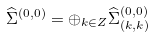<formula> <loc_0><loc_0><loc_500><loc_500>\widehat { \Sigma } ^ { ( 0 , 0 ) } = \oplus _ { k \in Z } \widehat { \Sigma } _ { ( k , k ) } ^ { ( 0 , 0 ) }</formula> 